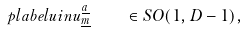Convert formula to latex. <formula><loc_0><loc_0><loc_500><loc_500>\ p l a b e l { u i n } u ^ { \underline { a } } _ { \underline { m } } \quad \in S O ( 1 , D - 1 ) ,</formula> 